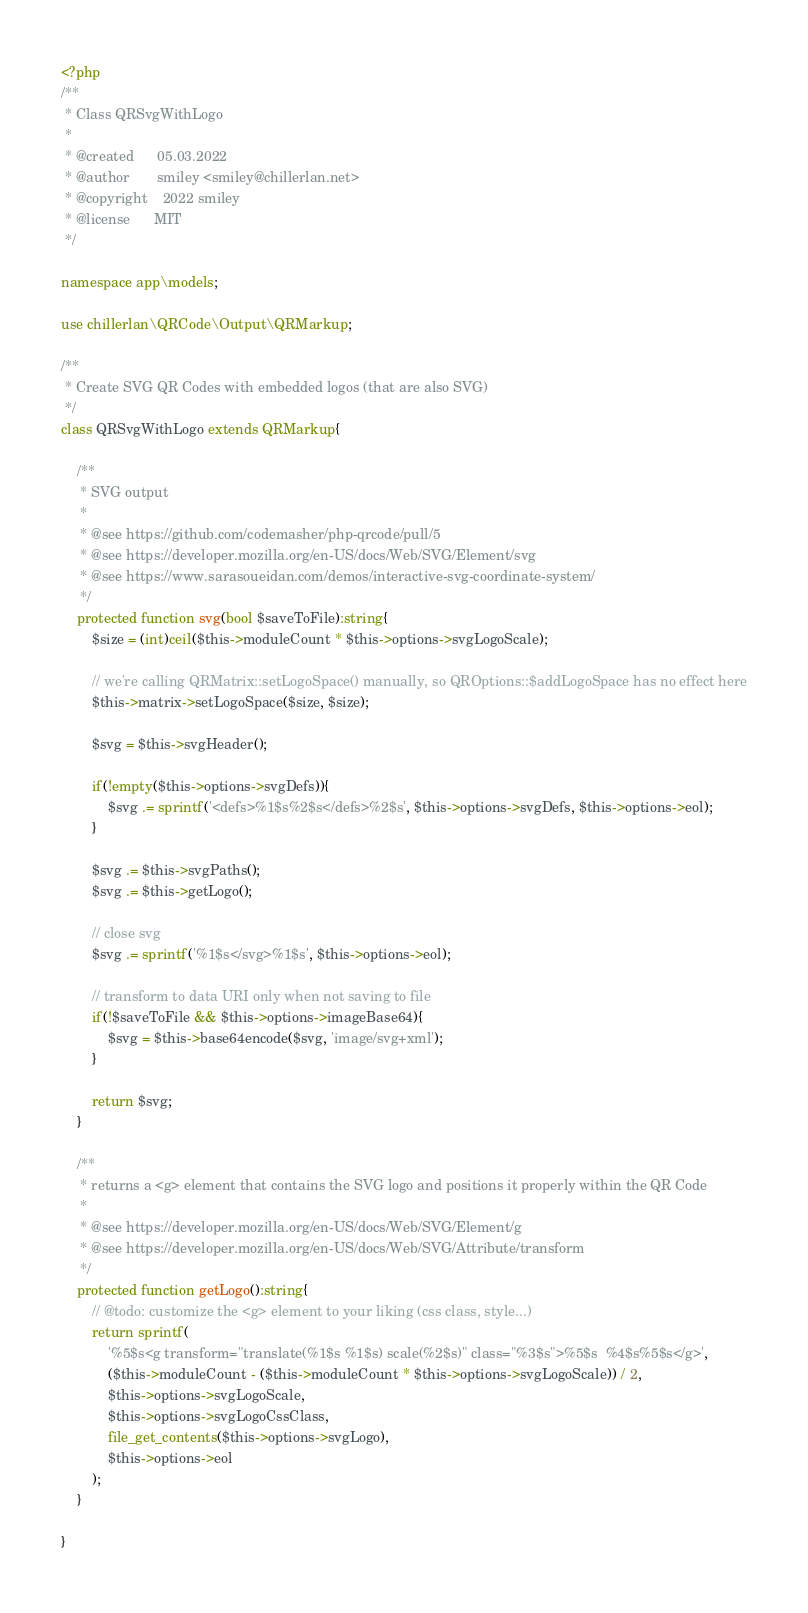<code> <loc_0><loc_0><loc_500><loc_500><_PHP_><?php
/**
 * Class QRSvgWithLogo
 *
 * @created      05.03.2022
 * @author       smiley <smiley@chillerlan.net>
 * @copyright    2022 smiley
 * @license      MIT
 */

namespace app\models;

use chillerlan\QRCode\Output\QRMarkup;

/**
 * Create SVG QR Codes with embedded logos (that are also SVG)
 */
class QRSvgWithLogo extends QRMarkup{

	/**
	 * SVG output
	 *
	 * @see https://github.com/codemasher/php-qrcode/pull/5
	 * @see https://developer.mozilla.org/en-US/docs/Web/SVG/Element/svg
	 * @see https://www.sarasoueidan.com/demos/interactive-svg-coordinate-system/
	 */
	protected function svg(bool $saveToFile):string{
		$size = (int)ceil($this->moduleCount * $this->options->svgLogoScale);

		// we're calling QRMatrix::setLogoSpace() manually, so QROptions::$addLogoSpace has no effect here
		$this->matrix->setLogoSpace($size, $size);

		$svg = $this->svgHeader();

		if(!empty($this->options->svgDefs)){
			$svg .= sprintf('<defs>%1$s%2$s</defs>%2$s', $this->options->svgDefs, $this->options->eol);
		}

		$svg .= $this->svgPaths();
		$svg .= $this->getLogo();

		// close svg
		$svg .= sprintf('%1$s</svg>%1$s', $this->options->eol);

		// transform to data URI only when not saving to file
		if(!$saveToFile && $this->options->imageBase64){
			$svg = $this->base64encode($svg, 'image/svg+xml');
		}

		return $svg;
	}

	/**
	 * returns a <g> element that contains the SVG logo and positions it properly within the QR Code
	 *
	 * @see https://developer.mozilla.org/en-US/docs/Web/SVG/Element/g
	 * @see https://developer.mozilla.org/en-US/docs/Web/SVG/Attribute/transform
	 */
	protected function getLogo():string{
		// @todo: customize the <g> element to your liking (css class, style...)
		return sprintf(
			'%5$s<g transform="translate(%1$s %1$s) scale(%2$s)" class="%3$s">%5$s	%4$s%5$s</g>',
			($this->moduleCount - ($this->moduleCount * $this->options->svgLogoScale)) / 2,
			$this->options->svgLogoScale,
			$this->options->svgLogoCssClass,
			file_get_contents($this->options->svgLogo),
			$this->options->eol
		);
	}

}
</code> 